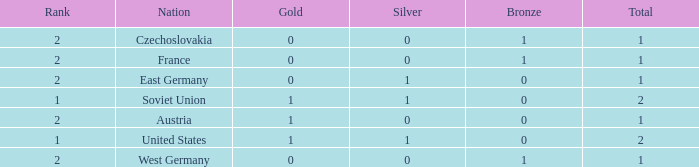What is the rank of the team with 0 gold and less than 0 silvers? None. 